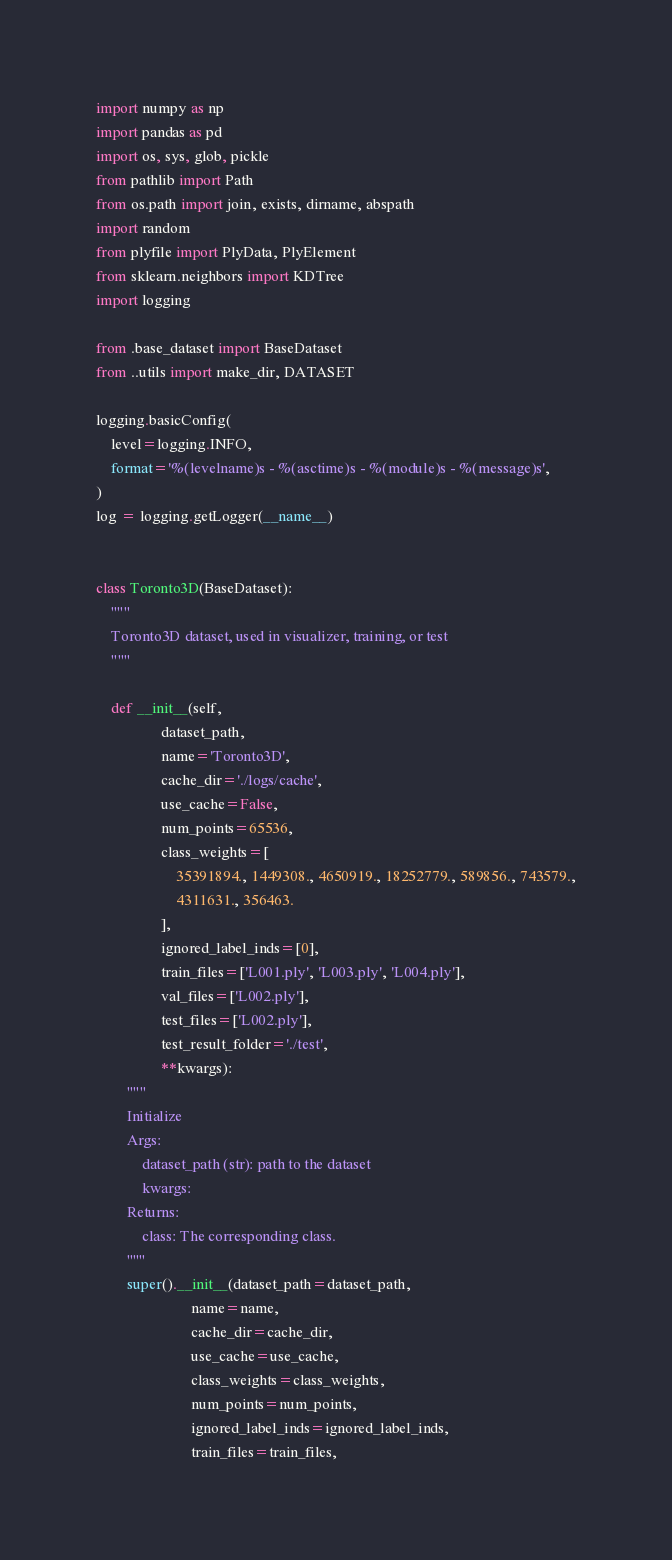<code> <loc_0><loc_0><loc_500><loc_500><_Python_>import numpy as np
import pandas as pd
import os, sys, glob, pickle
from pathlib import Path
from os.path import join, exists, dirname, abspath
import random
from plyfile import PlyData, PlyElement
from sklearn.neighbors import KDTree
import logging

from .base_dataset import BaseDataset
from ..utils import make_dir, DATASET

logging.basicConfig(
    level=logging.INFO,
    format='%(levelname)s - %(asctime)s - %(module)s - %(message)s',
)
log = logging.getLogger(__name__)


class Toronto3D(BaseDataset):
    """
    Toronto3D dataset, used in visualizer, training, or test
    """

    def __init__(self,
                 dataset_path,
                 name='Toronto3D',
                 cache_dir='./logs/cache',
                 use_cache=False,
                 num_points=65536,
                 class_weights=[
                     35391894., 1449308., 4650919., 18252779., 589856., 743579.,
                     4311631., 356463.
                 ],
                 ignored_label_inds=[0],
                 train_files=['L001.ply', 'L003.ply', 'L004.ply'],
                 val_files=['L002.ply'],
                 test_files=['L002.ply'],
                 test_result_folder='./test',
                 **kwargs):
        """
        Initialize
        Args:
            dataset_path (str): path to the dataset
            kwargs:
        Returns:
            class: The corresponding class.
        """
        super().__init__(dataset_path=dataset_path,
                         name=name,
                         cache_dir=cache_dir,
                         use_cache=use_cache,
                         class_weights=class_weights,
                         num_points=num_points,
                         ignored_label_inds=ignored_label_inds,
                         train_files=train_files,</code> 